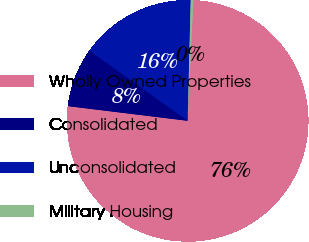Convert chart. <chart><loc_0><loc_0><loc_500><loc_500><pie_chart><fcel>Wholly Owned Properties<fcel>Consolidated<fcel>Unconsolidated<fcel>Military Housing<nl><fcel>76.19%<fcel>7.94%<fcel>15.52%<fcel>0.35%<nl></chart> 